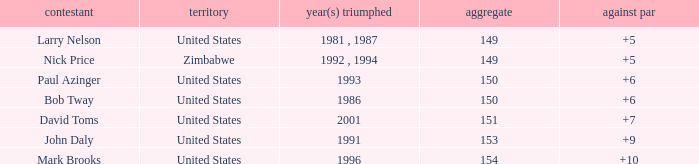Which player won in 1993? Paul Azinger. 